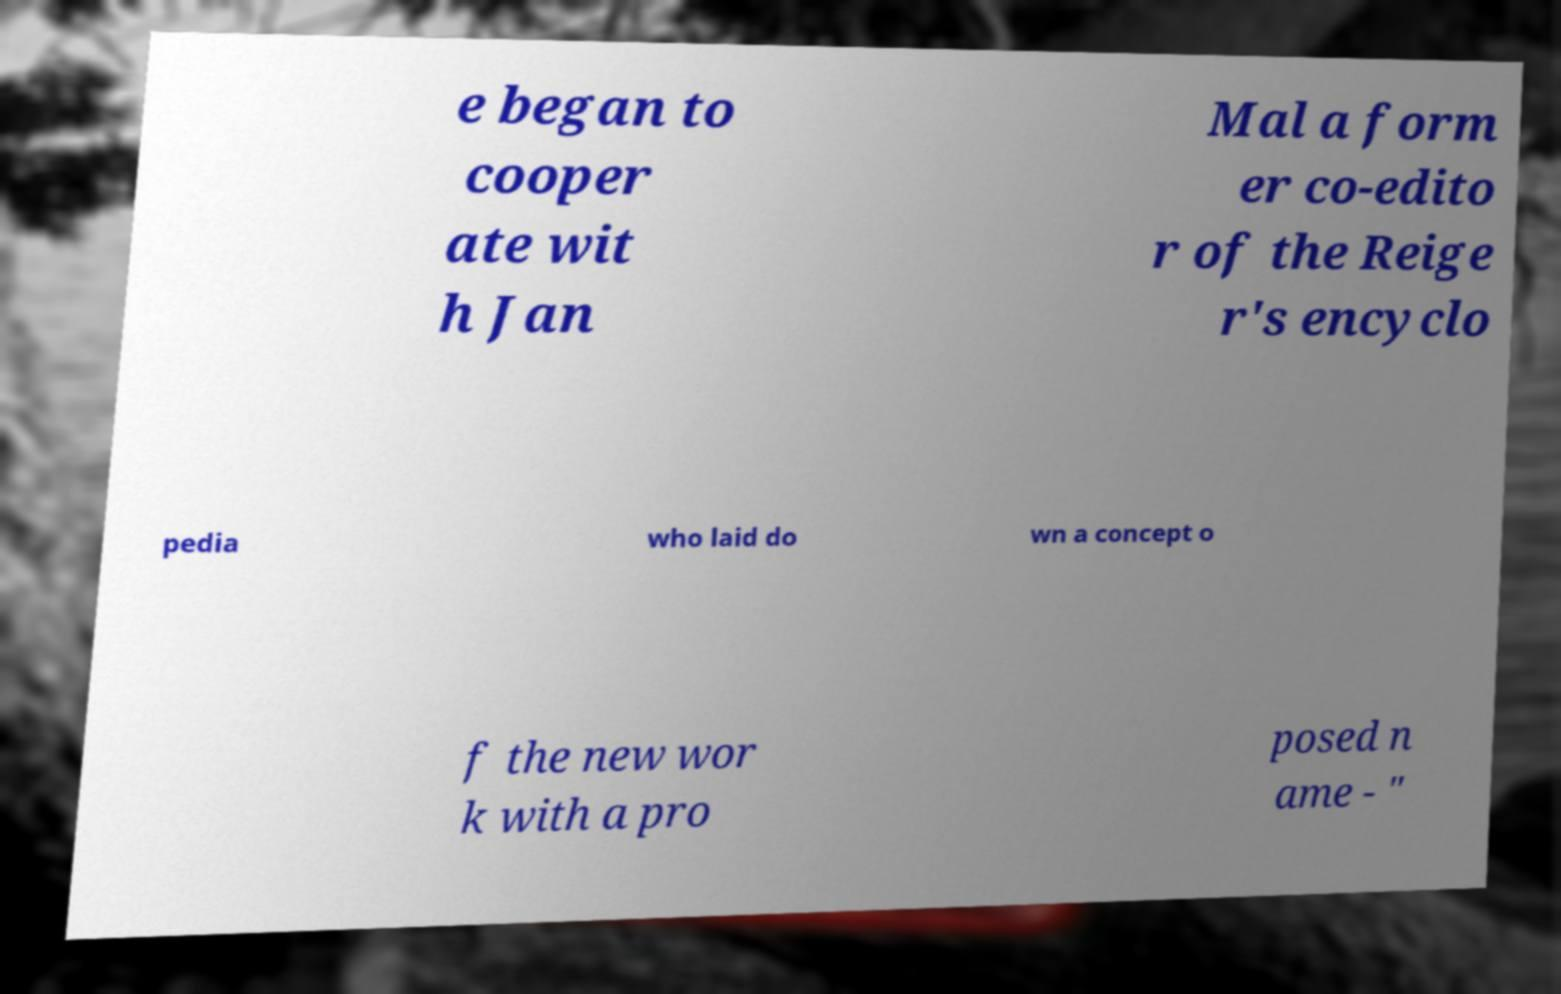Can you read and provide the text displayed in the image?This photo seems to have some interesting text. Can you extract and type it out for me? e began to cooper ate wit h Jan Mal a form er co-edito r of the Reige r's encyclo pedia who laid do wn a concept o f the new wor k with a pro posed n ame - " 